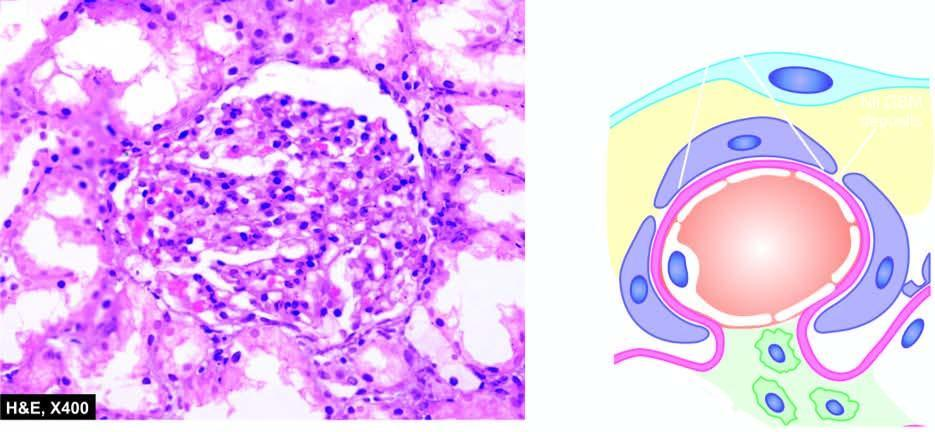what show cytoplasmic?
Answer the question using a single word or phrase. Tubules 